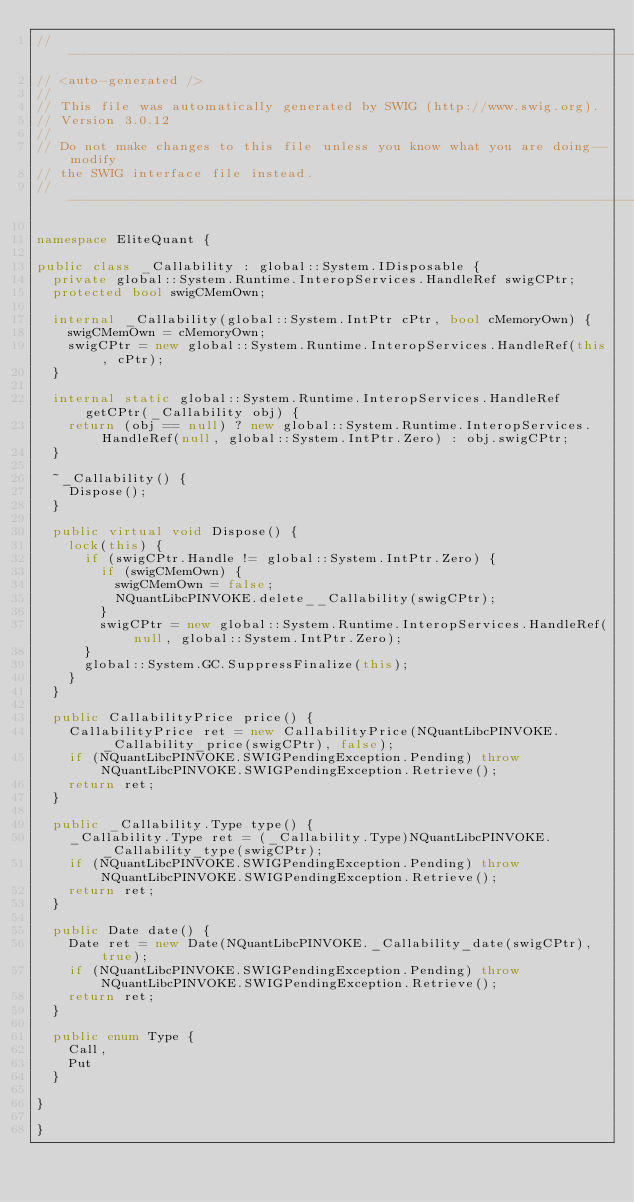<code> <loc_0><loc_0><loc_500><loc_500><_C#_>//------------------------------------------------------------------------------
// <auto-generated />
//
// This file was automatically generated by SWIG (http://www.swig.org).
// Version 3.0.12
//
// Do not make changes to this file unless you know what you are doing--modify
// the SWIG interface file instead.
//------------------------------------------------------------------------------

namespace EliteQuant {

public class _Callability : global::System.IDisposable {
  private global::System.Runtime.InteropServices.HandleRef swigCPtr;
  protected bool swigCMemOwn;

  internal _Callability(global::System.IntPtr cPtr, bool cMemoryOwn) {
    swigCMemOwn = cMemoryOwn;
    swigCPtr = new global::System.Runtime.InteropServices.HandleRef(this, cPtr);
  }

  internal static global::System.Runtime.InteropServices.HandleRef getCPtr(_Callability obj) {
    return (obj == null) ? new global::System.Runtime.InteropServices.HandleRef(null, global::System.IntPtr.Zero) : obj.swigCPtr;
  }

  ~_Callability() {
    Dispose();
  }

  public virtual void Dispose() {
    lock(this) {
      if (swigCPtr.Handle != global::System.IntPtr.Zero) {
        if (swigCMemOwn) {
          swigCMemOwn = false;
          NQuantLibcPINVOKE.delete__Callability(swigCPtr);
        }
        swigCPtr = new global::System.Runtime.InteropServices.HandleRef(null, global::System.IntPtr.Zero);
      }
      global::System.GC.SuppressFinalize(this);
    }
  }

  public CallabilityPrice price() {
    CallabilityPrice ret = new CallabilityPrice(NQuantLibcPINVOKE._Callability_price(swigCPtr), false);
    if (NQuantLibcPINVOKE.SWIGPendingException.Pending) throw NQuantLibcPINVOKE.SWIGPendingException.Retrieve();
    return ret;
  }

  public _Callability.Type type() {
    _Callability.Type ret = (_Callability.Type)NQuantLibcPINVOKE._Callability_type(swigCPtr);
    if (NQuantLibcPINVOKE.SWIGPendingException.Pending) throw NQuantLibcPINVOKE.SWIGPendingException.Retrieve();
    return ret;
  }

  public Date date() {
    Date ret = new Date(NQuantLibcPINVOKE._Callability_date(swigCPtr), true);
    if (NQuantLibcPINVOKE.SWIGPendingException.Pending) throw NQuantLibcPINVOKE.SWIGPendingException.Retrieve();
    return ret;
  }

  public enum Type {
    Call,
    Put
  }

}

}
</code> 